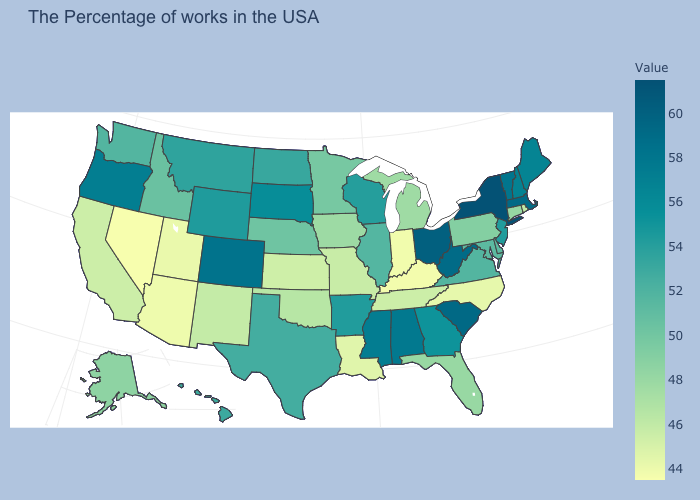Which states have the lowest value in the USA?
Quick response, please. Nevada. Among the states that border Virginia , does Kentucky have the lowest value?
Be succinct. Yes. Does California have a higher value than Colorado?
Short answer required. No. Among the states that border Kentucky , which have the highest value?
Short answer required. Ohio. 